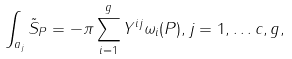<formula> <loc_0><loc_0><loc_500><loc_500>\int _ { a _ { j } } \tilde { S } _ { P } = - \pi \sum _ { i = 1 } ^ { g } Y ^ { i j } \omega _ { i } ( P ) , j = 1 , \dots c , g ,</formula> 